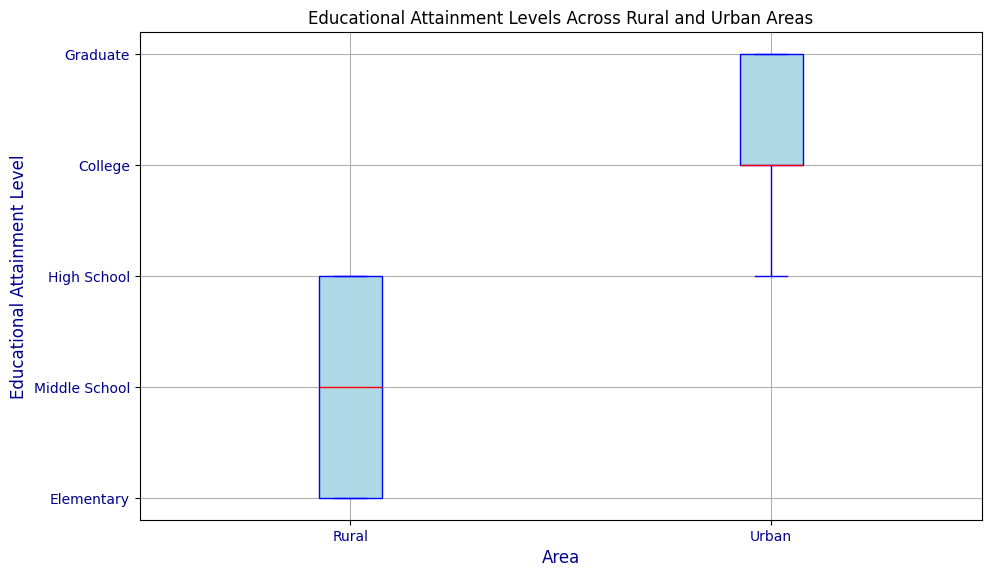What are the median educational attainment levels in rural and urban areas? Looking at the median line in each box plot, the rural area's median is at the 'High School' level, while the urban area's median is at the 'College' level.
Answer: Rural: High School, Urban: College Which area has the highest variability in educational attainment levels? Variability in the box plot is indicated by the length of the box and whiskers. The rural area shows a wider spread from 'Elementary' to 'High School', indicating higher variability compared to the urban area.
Answer: Rural Which group has a higher maximum educational attainment level? The top whisker of the box plot indicates the maximum value. Both rural and urban areas have a Graduate level as the highest attainment, but visually, urban might slightly extend higher.
Answer: Urban What is the interquartile range (IQR) of educational attainment levels in urban areas? The IQR is the difference between the upper quartile (75th percentile) and lower quartile (25th percentile). For the urban area, the IQR spans from 'College' to 'Graduate'. Mapping these to numeric values, the IQR is 5 - 4 = 1.
Answer: 1 Which educational attainment level is more common in rural areas than in urban areas? The median line and the spread of the box plot segments suggest 'High School' attainment is more concentrated in rural areas, whereas in urban areas ‘College’ and ‘Graduate’ levels dominate more.
Answer: High School Is there any overlap in the educational attainment levels between rural and urban areas? By examining the ranges of the educational levels from both box plots, we can see an overlap from 'Elementary' to 'Graduate' levels in both areas.
Answer: Yes What is the range of educational attainment levels in rural areas? The range is determined by the smallest and largest values. For rural areas, it ranges from 'Elementary' to 'High School'. Mapping these to numeric values, the range is 3 - 1 = 2.
Answer: Elementary to High School How does the median educational attainment levels of rural areas compare to that of urban areas? The box plot clearly shows that the median for rural areas is at 'High School', while the urban median is one level higher at 'College'.
Answer: Rural: High School, Urban: College 